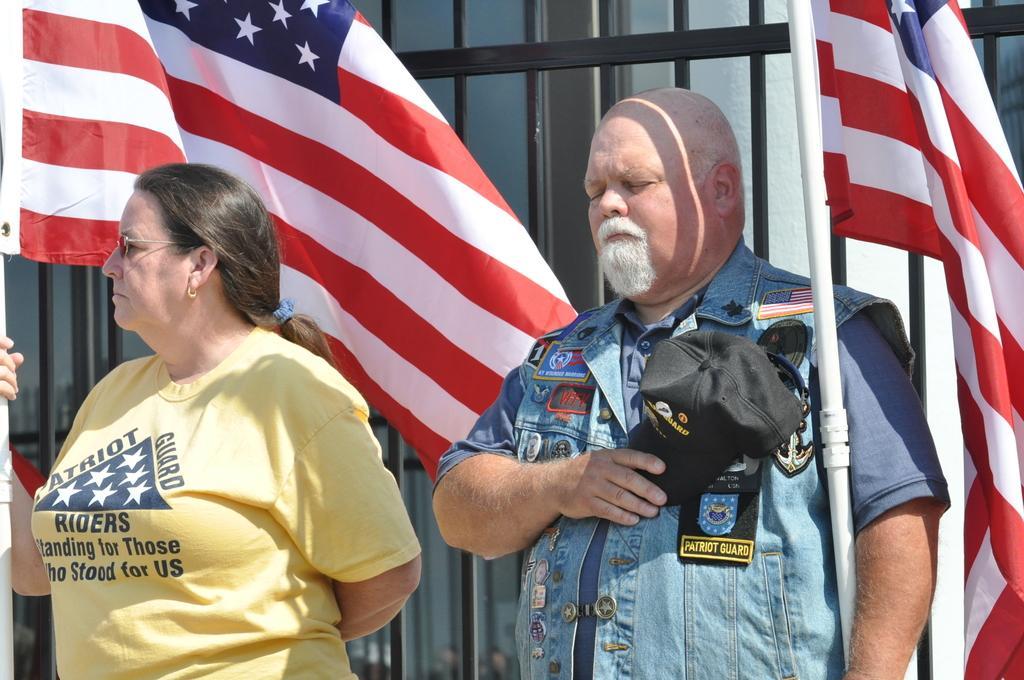How would you summarize this image in a sentence or two? In this image in the center there is one man and one woman who are standing and man is holding a cap, and he is holding a pole and flag and woman also holding one pole and flag. In the background there is a fence and wall. 